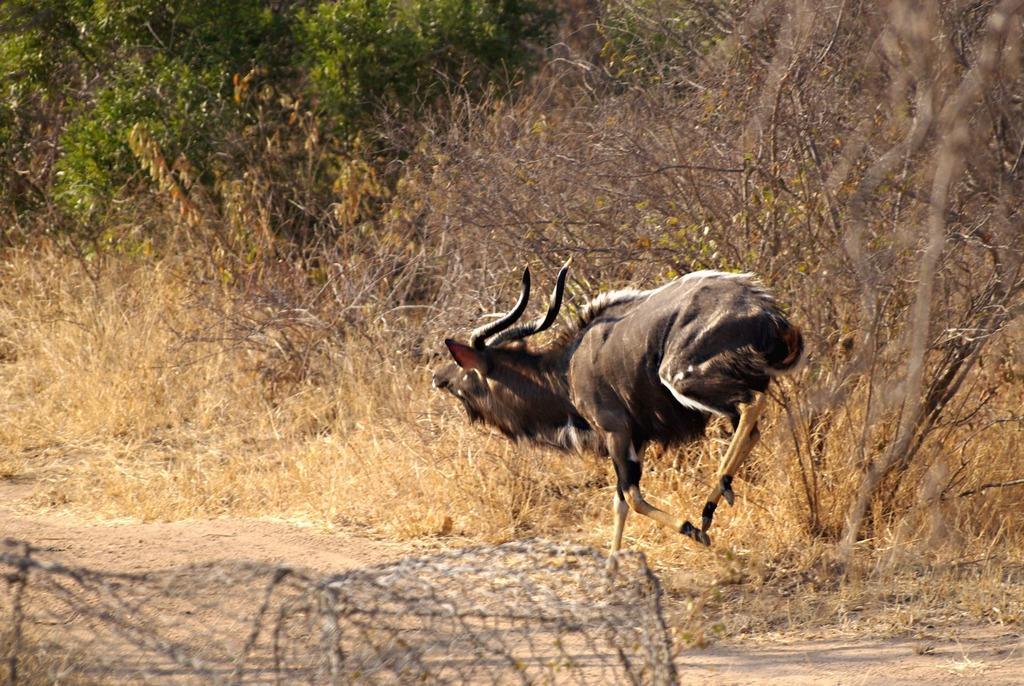In one or two sentences, can you explain what this image depicts? In this image we can see one animal running on the road, some trees, some bushes, some grass and one object on the surface. 